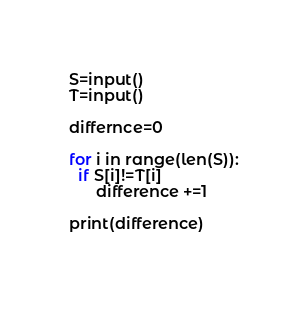Convert code to text. <code><loc_0><loc_0><loc_500><loc_500><_Python_>S=input()
T=input()
 
differnce=0
 
for i in range(len(S)):
  if S[i]!=T[i]
      difference +=1
 
print(difference)
 </code> 